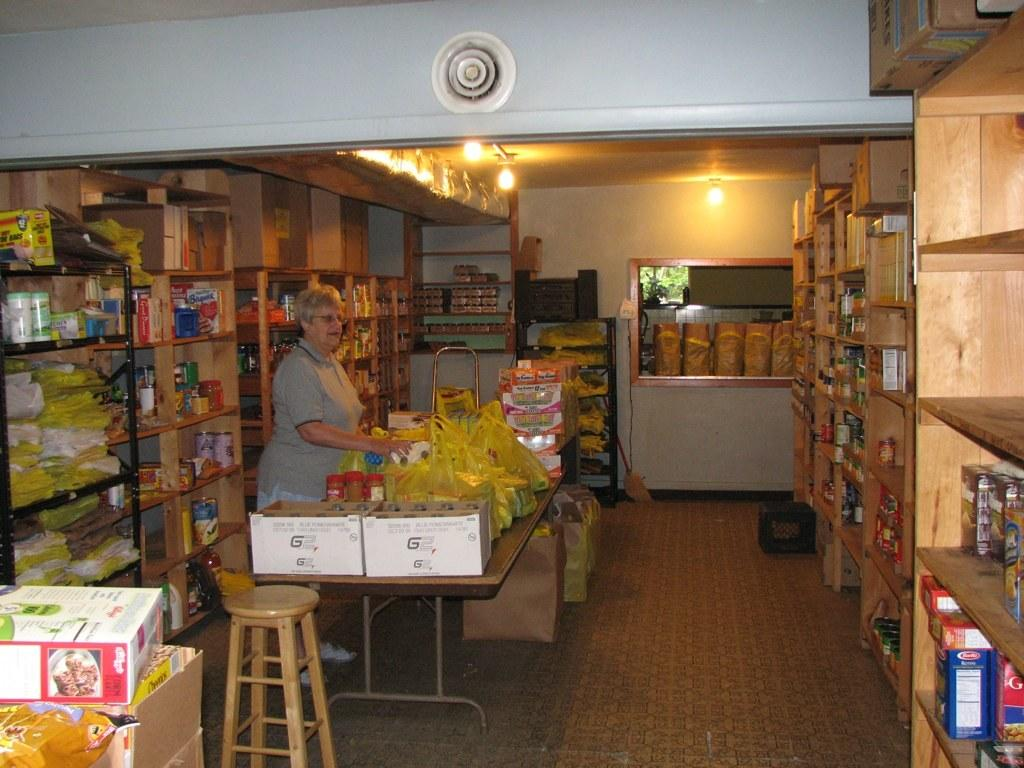What type of establishment is depicted in the image? There is a general store in the image. Can you describe the people in the image? There is a woman on the left side of the image. What type of whistle can be heard coming from the geese in the image? There are no geese or whistles present in the image. What belief system is represented by the woman in the image? The image does not provide any information about the woman's belief system. 